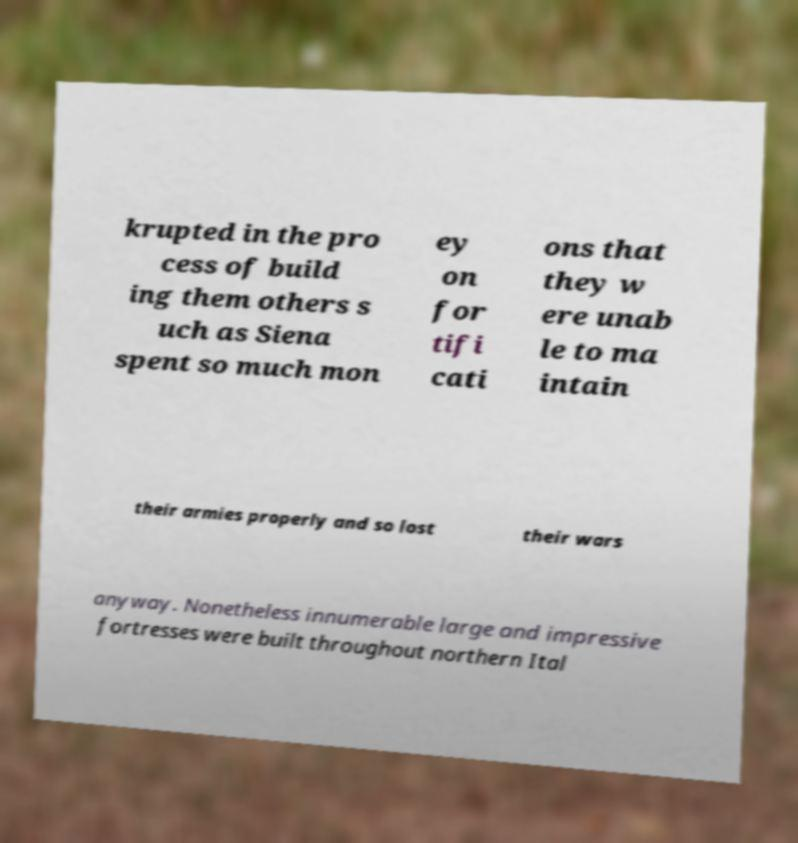Can you accurately transcribe the text from the provided image for me? krupted in the pro cess of build ing them others s uch as Siena spent so much mon ey on for tifi cati ons that they w ere unab le to ma intain their armies properly and so lost their wars anyway. Nonetheless innumerable large and impressive fortresses were built throughout northern Ital 